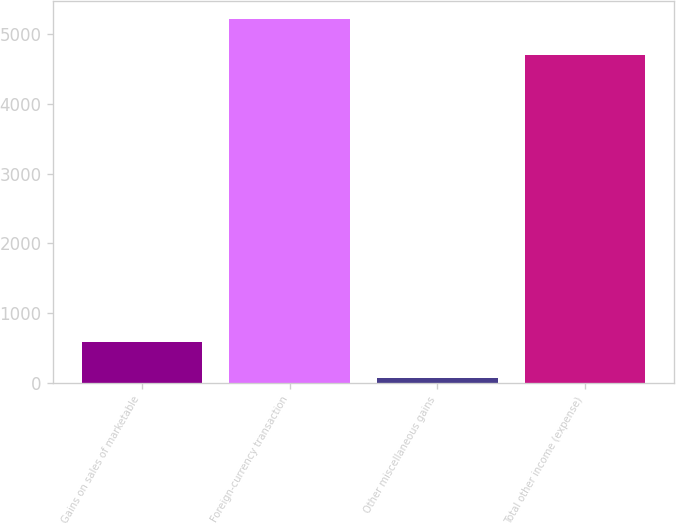Convert chart. <chart><loc_0><loc_0><loc_500><loc_500><bar_chart><fcel>Gains on sales of marketable<fcel>Foreign-currency transaction<fcel>Other miscellaneous gains<fcel>Total other income (expense)<nl><fcel>587.1<fcel>5215.1<fcel>73<fcel>4701<nl></chart> 